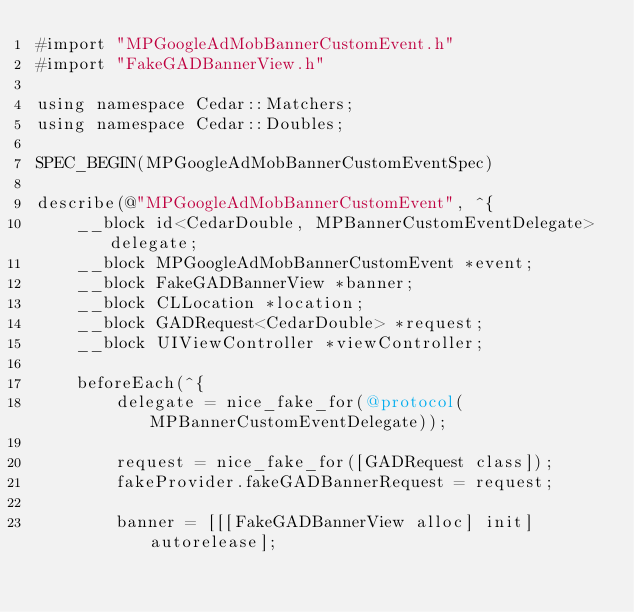<code> <loc_0><loc_0><loc_500><loc_500><_ObjectiveC_>#import "MPGoogleAdMobBannerCustomEvent.h"
#import "FakeGADBannerView.h"

using namespace Cedar::Matchers;
using namespace Cedar::Doubles;

SPEC_BEGIN(MPGoogleAdMobBannerCustomEventSpec)

describe(@"MPGoogleAdMobBannerCustomEvent", ^{
    __block id<CedarDouble, MPBannerCustomEventDelegate> delegate;
    __block MPGoogleAdMobBannerCustomEvent *event;
    __block FakeGADBannerView *banner;
    __block CLLocation *location;
    __block GADRequest<CedarDouble> *request;
    __block UIViewController *viewController;

    beforeEach(^{
        delegate = nice_fake_for(@protocol(MPBannerCustomEventDelegate));

        request = nice_fake_for([GADRequest class]);
        fakeProvider.fakeGADBannerRequest = request;

        banner = [[[FakeGADBannerView alloc] init] autorelease];</code> 